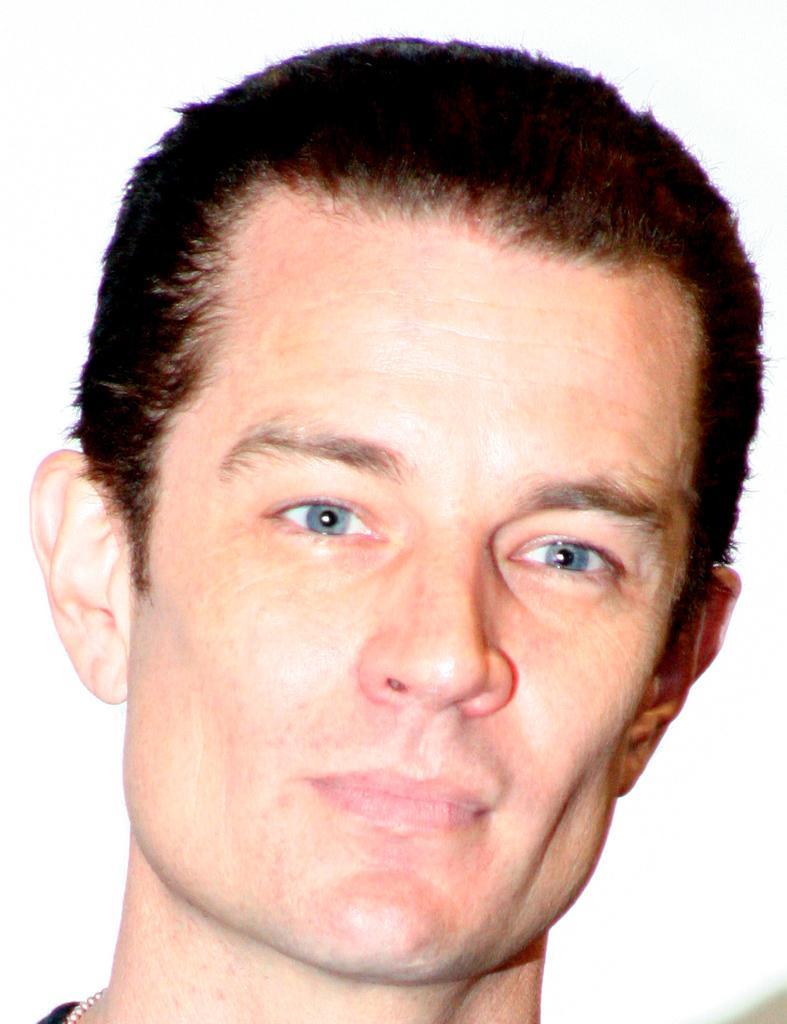Can you describe this image briefly? As we can see in the image there is a man face. 